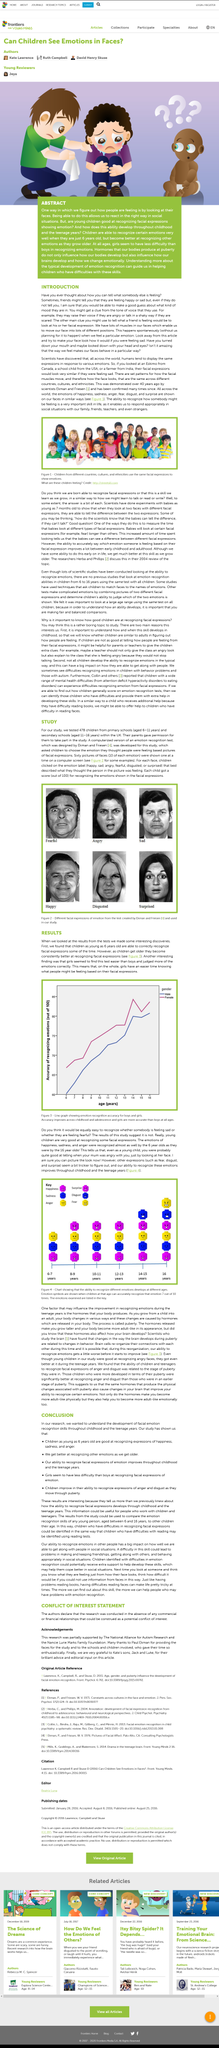Outline some significant characteristics in this image. Yes, as children age, they become more skilled at identifying facial expressions. The caption conveys that the facial expressions in the photos are from the test created by Ekman and Friesen and used in the study. Yes, humans display the same expressions to show emotions around the world. Research has shown that gender can play a role in a person's ability to read and interpret facial expressions, with some studies suggesting that women may have an advantage in this area. It is possible for children as young as 6 years old to correctly recognize facial expressions some of the time. 